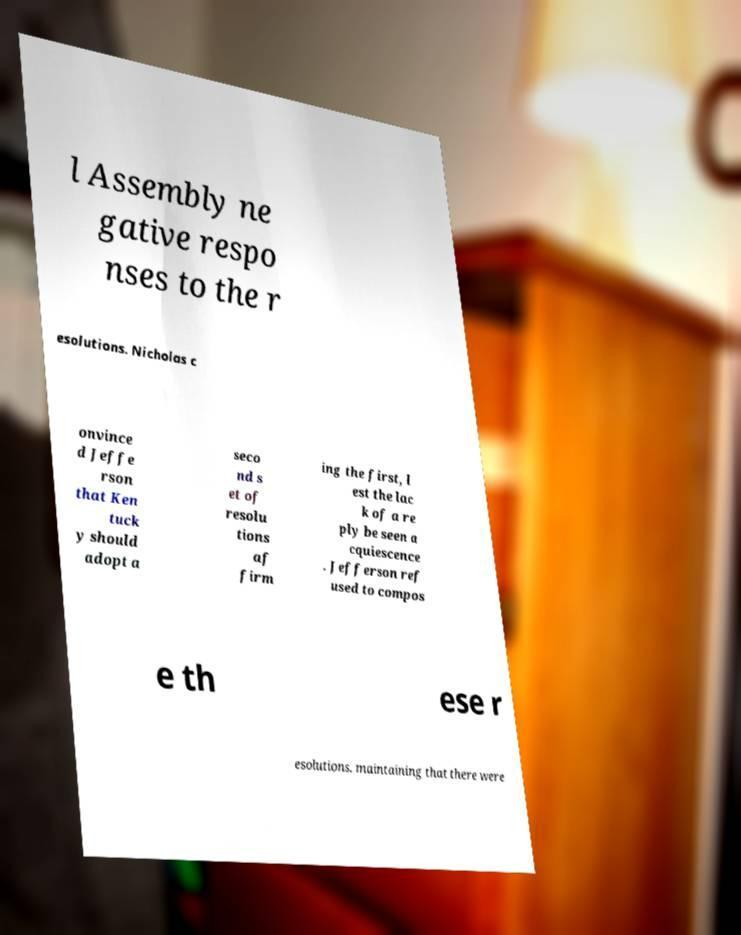Please read and relay the text visible in this image. What does it say? l Assembly ne gative respo nses to the r esolutions. Nicholas c onvince d Jeffe rson that Ken tuck y should adopt a seco nd s et of resolu tions af firm ing the first, l est the lac k of a re ply be seen a cquiescence . Jefferson ref used to compos e th ese r esolutions, maintaining that there were 